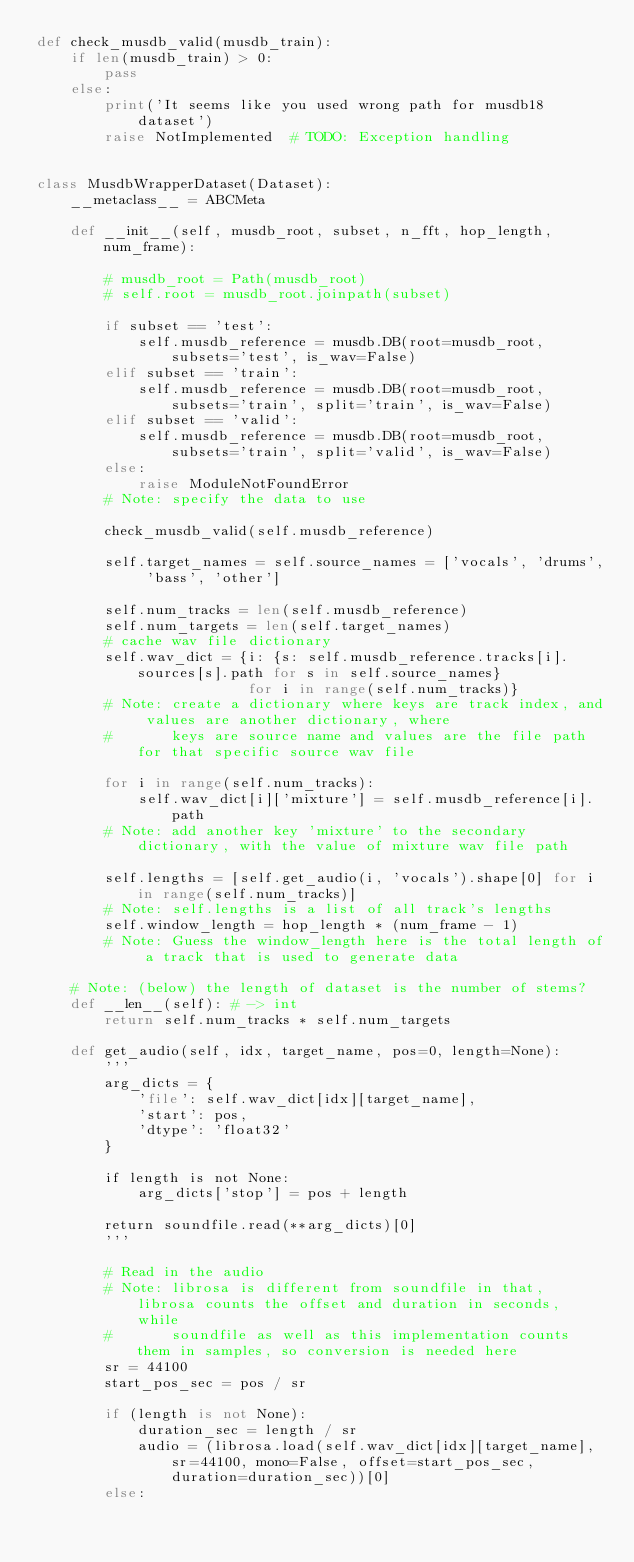Convert code to text. <code><loc_0><loc_0><loc_500><loc_500><_Python_>def check_musdb_valid(musdb_train):
    if len(musdb_train) > 0:
        pass
    else:
        print('It seems like you used wrong path for musdb18 dataset')
        raise NotImplemented  # TODO: Exception handling


class MusdbWrapperDataset(Dataset):
    __metaclass__ = ABCMeta

    def __init__(self, musdb_root, subset, n_fft, hop_length, num_frame):

        # musdb_root = Path(musdb_root)
        # self.root = musdb_root.joinpath(subset)

        if subset == 'test':
            self.musdb_reference = musdb.DB(root=musdb_root, subsets='test', is_wav=False)
        elif subset == 'train':
            self.musdb_reference = musdb.DB(root=musdb_root, subsets='train', split='train', is_wav=False)
        elif subset == 'valid':
            self.musdb_reference = musdb.DB(root=musdb_root, subsets='train', split='valid', is_wav=False)
        else:
            raise ModuleNotFoundError
        # Note: specify the data to use

        check_musdb_valid(self.musdb_reference)

        self.target_names = self.source_names = ['vocals', 'drums', 'bass', 'other']

        self.num_tracks = len(self.musdb_reference)
        self.num_targets = len(self.target_names)
        # cache wav file dictionary
        self.wav_dict = {i: {s: self.musdb_reference.tracks[i].sources[s].path for s in self.source_names}
                         for i in range(self.num_tracks)}
        # Note: create a dictionary where keys are track index, and values are another dictionary, where
        #       keys are source name and values are the file path for that specific source wav file

        for i in range(self.num_tracks):
            self.wav_dict[i]['mixture'] = self.musdb_reference[i].path
        # Note: add another key 'mixture' to the secondary dictionary, with the value of mixture wav file path

        self.lengths = [self.get_audio(i, 'vocals').shape[0] for i in range(self.num_tracks)]
        # Note: self.lengths is a list of all track's lengths
        self.window_length = hop_length * (num_frame - 1)
        # Note: Guess the window_length here is the total length of a track that is used to generate data

    # Note: (below) the length of dataset is the number of stems?
    def __len__(self): # -> int
        return self.num_tracks * self.num_targets

    def get_audio(self, idx, target_name, pos=0, length=None):
        '''
        arg_dicts = {
            'file': self.wav_dict[idx][target_name],
            'start': pos,
            'dtype': 'float32'
        }

        if length is not None:
            arg_dicts['stop'] = pos + length

        return soundfile.read(**arg_dicts)[0]
        '''
        
        # Read in the audio
        # Note: librosa is different from soundfile in that, librosa counts the offset and duration in seconds, while
        #       soundfile as well as this implementation counts them in samples, so conversion is needed here
        sr = 44100
        start_pos_sec = pos / sr
        
        if (length is not None):
            duration_sec = length / sr
            audio = (librosa.load(self.wav_dict[idx][target_name], sr=44100, mono=False, offset=start_pos_sec, duration=duration_sec))[0]
        else:</code> 